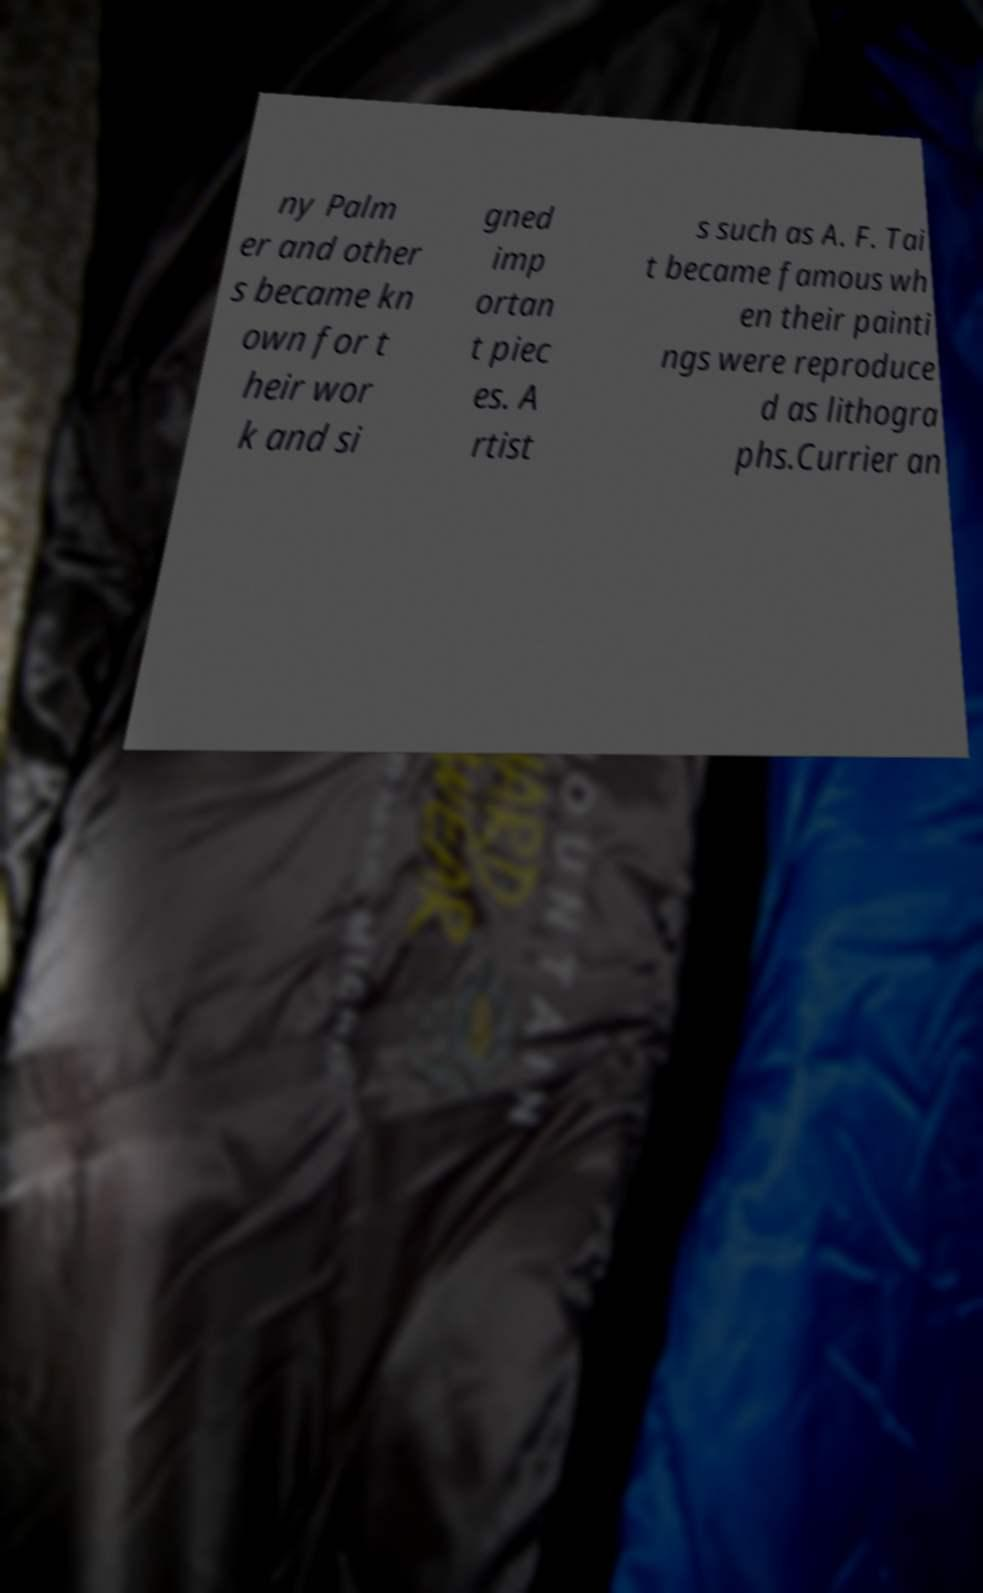For documentation purposes, I need the text within this image transcribed. Could you provide that? ny Palm er and other s became kn own for t heir wor k and si gned imp ortan t piec es. A rtist s such as A. F. Tai t became famous wh en their painti ngs were reproduce d as lithogra phs.Currier an 